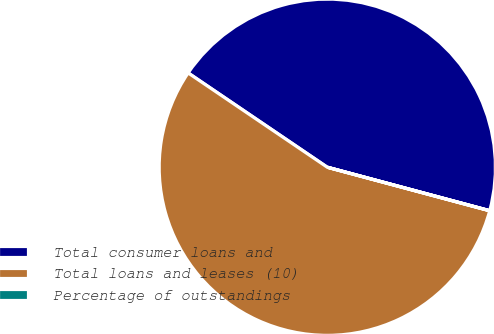Convert chart to OTSL. <chart><loc_0><loc_0><loc_500><loc_500><pie_chart><fcel>Total consumer loans and<fcel>Total loans and leases (10)<fcel>Percentage of outstandings<nl><fcel>44.68%<fcel>55.31%<fcel>0.01%<nl></chart> 